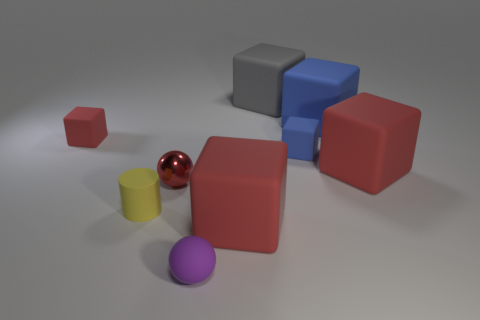There is a ball in front of the red sphere; what color is it?
Your answer should be very brief. Purple. There is a rubber ball that is the same size as the red metallic ball; what is its color?
Make the answer very short. Purple. Do the red metallic ball and the yellow matte object have the same size?
Your response must be concise. Yes. There is a gray rubber thing; how many red objects are on the left side of it?
Provide a short and direct response. 3. How many things are red blocks behind the red metallic thing or tiny blue rubber blocks?
Offer a terse response. 3. Are there more tiny balls that are behind the purple thing than small blue matte blocks in front of the yellow rubber object?
Make the answer very short. Yes. Does the rubber ball have the same size as the metallic ball behind the purple ball?
Keep it short and to the point. Yes. What number of cylinders are small blue rubber objects or tiny red things?
Make the answer very short. 0. What size is the gray object that is the same material as the tiny purple thing?
Your answer should be compact. Large. There is a object that is behind the large blue matte block; is it the same size as the red cube that is in front of the tiny metallic sphere?
Provide a succinct answer. Yes. 